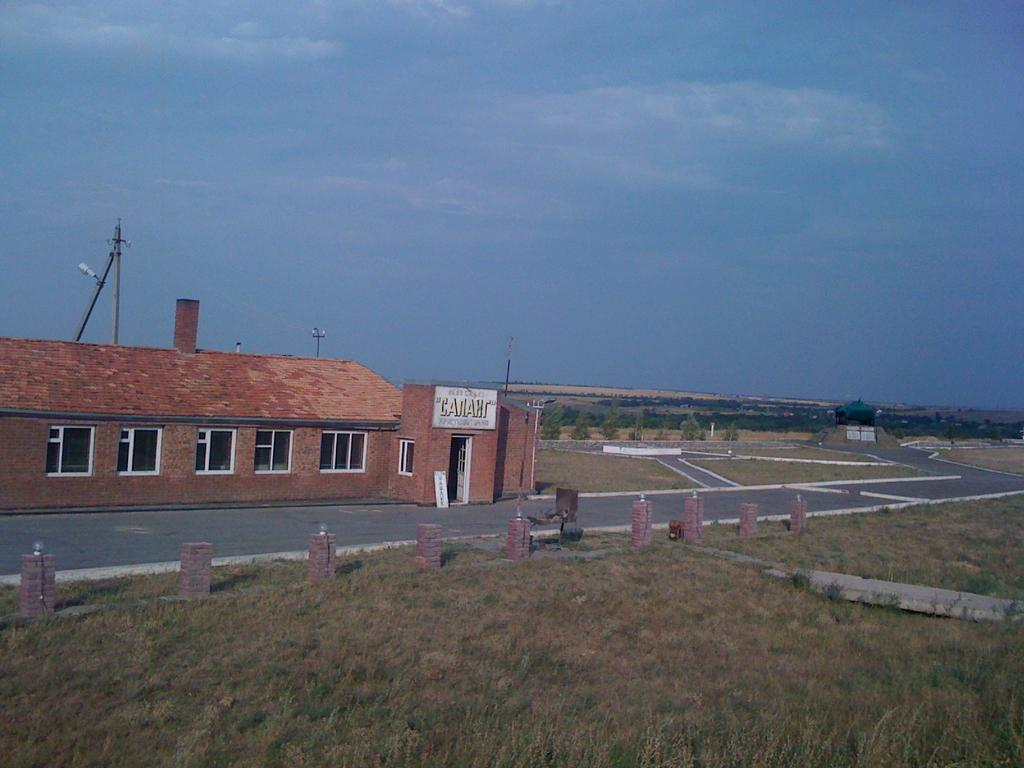What type of structure is visible in the image? There is a building in the image. What is in front of the building? There is a road and a gate in front of the building. What can be seen on the ground in the image? The ground is visible in the image. What architectural features are present in the image? There are pillars with lights in the image. What type of lighting is present in the image? There are street lights in the image. What type of vegetation is visible in the image? There are trees in the image. What is visible in the background of the image? The sky is visible in the image. What type of scissors can be seen cutting the trees in the image? There are no scissors visible in the image, and no trees are being cut. 